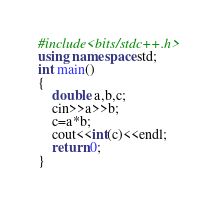Convert code to text. <code><loc_0><loc_0><loc_500><loc_500><_C++_>#include<bits/stdc++.h>
using namespace std;
int main()
{
    double a,b,c;
    cin>>a>>b;
    c=a*b;
    cout<<int(c)<<endl;
    return 0;
}</code> 